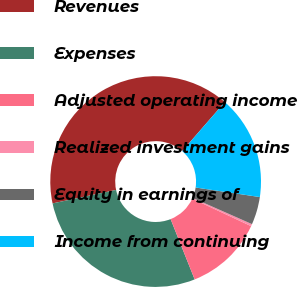Convert chart. <chart><loc_0><loc_0><loc_500><loc_500><pie_chart><fcel>Revenues<fcel>Expenses<fcel>Adjusted operating income<fcel>Realized investment gains<fcel>Equity in earnings of<fcel>Income from continuing<nl><fcel>39.73%<fcel>27.72%<fcel>12.01%<fcel>0.33%<fcel>4.27%<fcel>15.95%<nl></chart> 